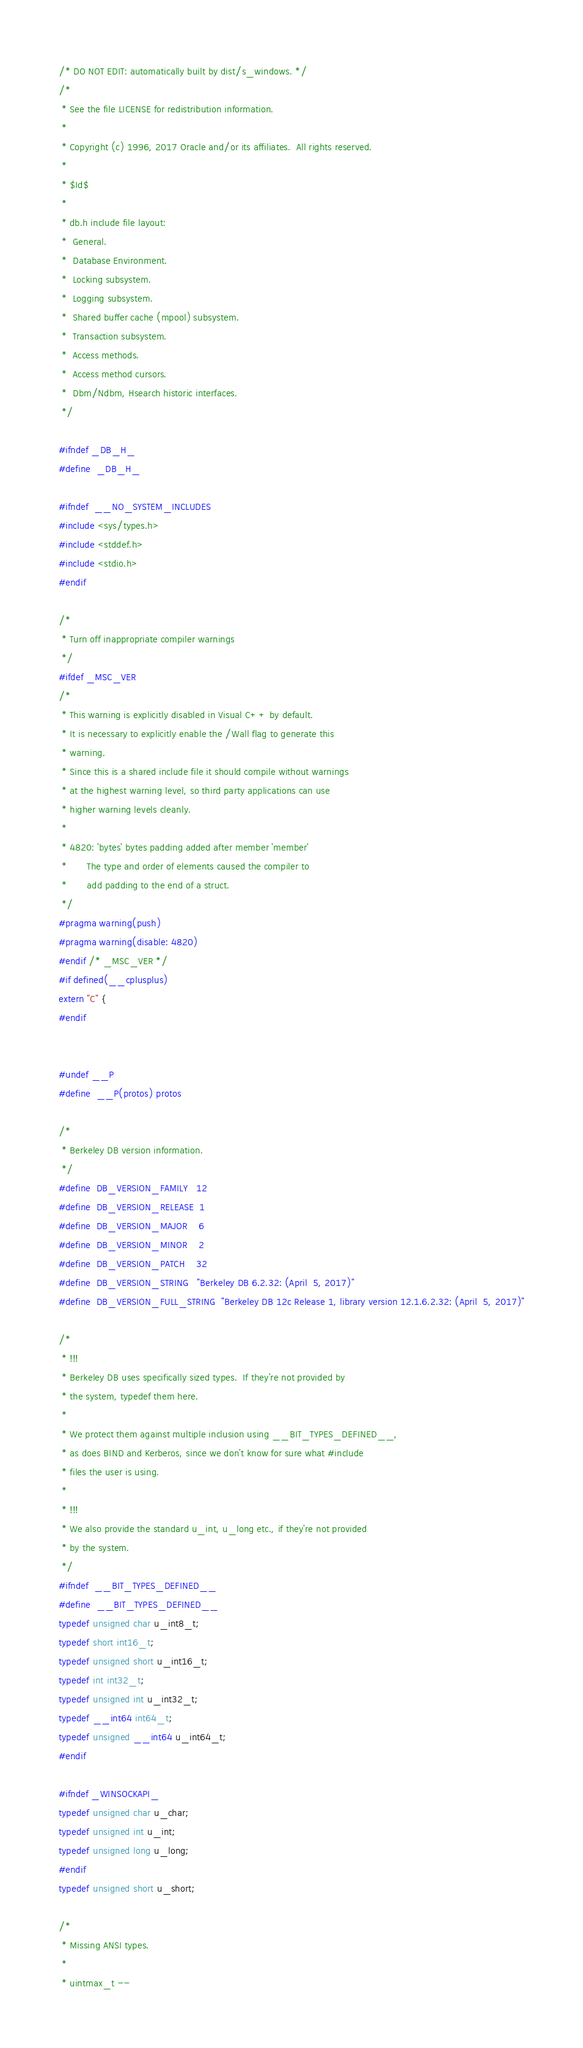Convert code to text. <code><loc_0><loc_0><loc_500><loc_500><_C_>/* DO NOT EDIT: automatically built by dist/s_windows. */
/*
 * See the file LICENSE for redistribution information.
 *
 * Copyright (c) 1996, 2017 Oracle and/or its affiliates.  All rights reserved.
 *
 * $Id$
 *
 * db.h include file layout:
 *	General.
 *	Database Environment.
 *	Locking subsystem.
 *	Logging subsystem.
 *	Shared buffer cache (mpool) subsystem.
 *	Transaction subsystem.
 *	Access methods.
 *	Access method cursors.
 *	Dbm/Ndbm, Hsearch historic interfaces.
 */

#ifndef _DB_H_
#define	_DB_H_

#ifndef	__NO_SYSTEM_INCLUDES
#include <sys/types.h>
#include <stddef.h>
#include <stdio.h>
#endif

/*
 * Turn off inappropriate compiler warnings
 */
#ifdef _MSC_VER
/*
 * This warning is explicitly disabled in Visual C++ by default.
 * It is necessary to explicitly enable the /Wall flag to generate this
 * warning.
 * Since this is a shared include file it should compile without warnings
 * at the highest warning level, so third party applications can use
 * higher warning levels cleanly.
 *
 * 4820: 'bytes' bytes padding added after member 'member'
 *       The type and order of elements caused the compiler to
 *       add padding to the end of a struct.
 */
#pragma warning(push)
#pragma warning(disable: 4820)
#endif /* _MSC_VER */
#if defined(__cplusplus)
extern "C" {
#endif


#undef __P
#define	__P(protos)	protos

/*
 * Berkeley DB version information.
 */
#define	DB_VERSION_FAMILY	12
#define	DB_VERSION_RELEASE	1
#define	DB_VERSION_MAJOR	6
#define	DB_VERSION_MINOR	2
#define	DB_VERSION_PATCH	32
#define	DB_VERSION_STRING	"Berkeley DB 6.2.32: (April  5, 2017)"
#define	DB_VERSION_FULL_STRING	"Berkeley DB 12c Release 1, library version 12.1.6.2.32: (April  5, 2017)"

/*
 * !!!
 * Berkeley DB uses specifically sized types.  If they're not provided by
 * the system, typedef them here.
 *
 * We protect them against multiple inclusion using __BIT_TYPES_DEFINED__,
 * as does BIND and Kerberos, since we don't know for sure what #include
 * files the user is using.
 *
 * !!!
 * We also provide the standard u_int, u_long etc., if they're not provided
 * by the system.
 */
#ifndef	__BIT_TYPES_DEFINED__
#define	__BIT_TYPES_DEFINED__
typedef unsigned char u_int8_t;
typedef short int16_t;
typedef unsigned short u_int16_t;
typedef int int32_t;
typedef unsigned int u_int32_t;
typedef __int64 int64_t;
typedef unsigned __int64 u_int64_t;
#endif

#ifndef _WINSOCKAPI_
typedef unsigned char u_char;
typedef unsigned int u_int;
typedef unsigned long u_long;
#endif
typedef unsigned short u_short;

/*
 * Missing ANSI types.
 *
 * uintmax_t --</code> 